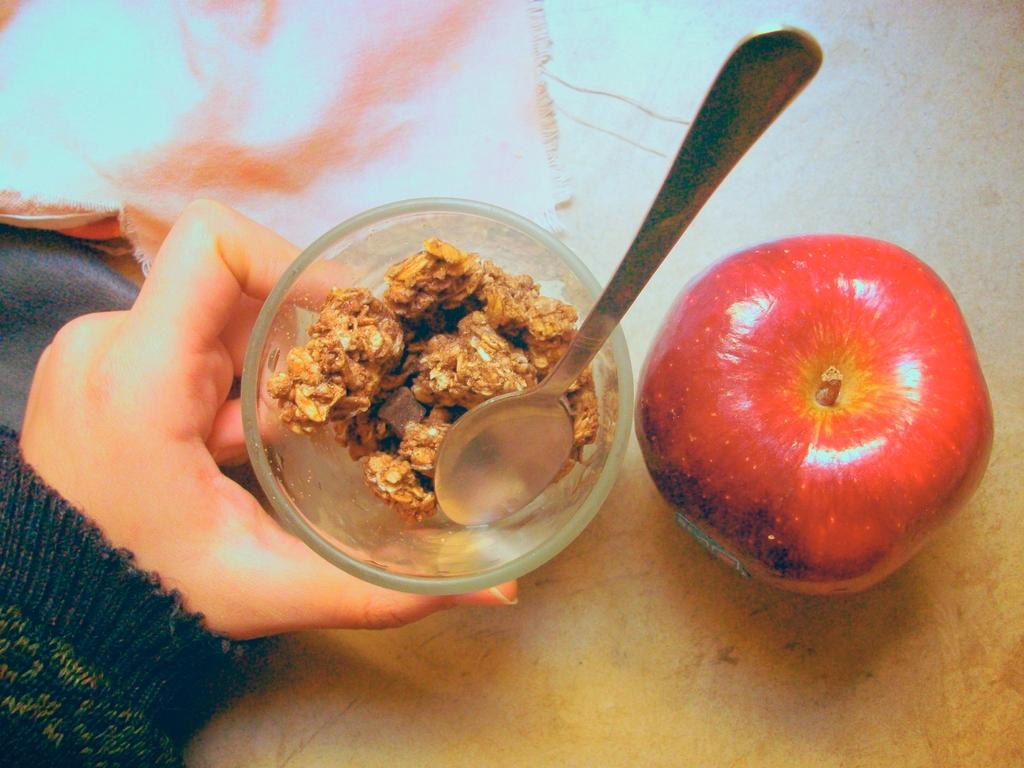What is the main object in the image? There is an apple in the image. What is the person's hand doing in the image? The person's hand is holding a bowl in the image. What type of food is in the bowl? The bowl contains food that is brown in color. What utensil is visible in the image? There is a spoon visible in the image. Can you tell me how many businesses are visible in the image? There are no businesses visible in the image. What type of sea creature can be seen swimming in the image? There is no sea or sea creature present in the image. 